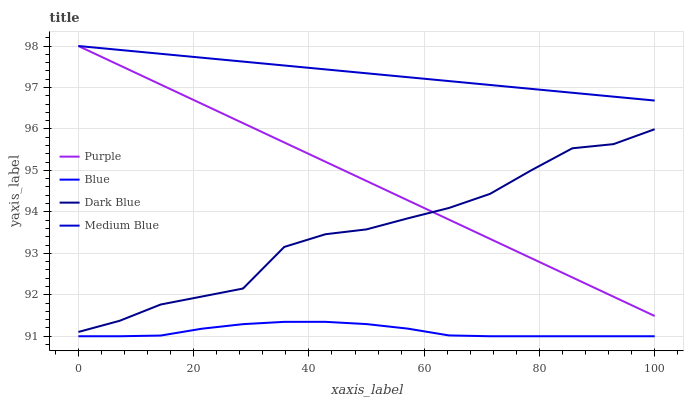Does Blue have the minimum area under the curve?
Answer yes or no. Yes. Does Medium Blue have the maximum area under the curve?
Answer yes or no. Yes. Does Medium Blue have the minimum area under the curve?
Answer yes or no. No. Does Blue have the maximum area under the curve?
Answer yes or no. No. Is Medium Blue the smoothest?
Answer yes or no. Yes. Is Dark Blue the roughest?
Answer yes or no. Yes. Is Blue the smoothest?
Answer yes or no. No. Is Blue the roughest?
Answer yes or no. No. Does Blue have the lowest value?
Answer yes or no. Yes. Does Medium Blue have the lowest value?
Answer yes or no. No. Does Medium Blue have the highest value?
Answer yes or no. Yes. Does Blue have the highest value?
Answer yes or no. No. Is Blue less than Purple?
Answer yes or no. Yes. Is Medium Blue greater than Dark Blue?
Answer yes or no. Yes. Does Dark Blue intersect Purple?
Answer yes or no. Yes. Is Dark Blue less than Purple?
Answer yes or no. No. Is Dark Blue greater than Purple?
Answer yes or no. No. Does Blue intersect Purple?
Answer yes or no. No. 